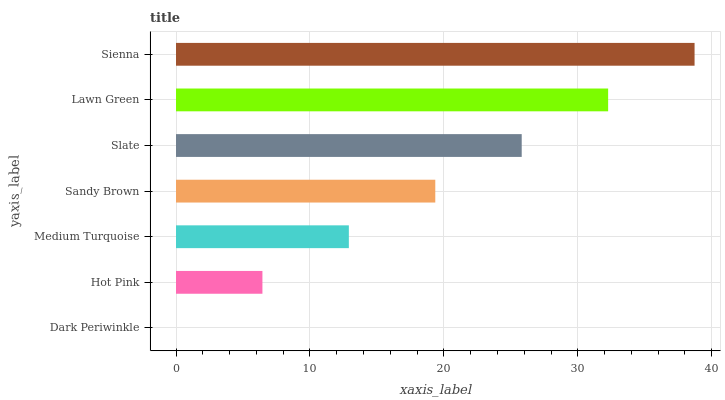Is Dark Periwinkle the minimum?
Answer yes or no. Yes. Is Sienna the maximum?
Answer yes or no. Yes. Is Hot Pink the minimum?
Answer yes or no. No. Is Hot Pink the maximum?
Answer yes or no. No. Is Hot Pink greater than Dark Periwinkle?
Answer yes or no. Yes. Is Dark Periwinkle less than Hot Pink?
Answer yes or no. Yes. Is Dark Periwinkle greater than Hot Pink?
Answer yes or no. No. Is Hot Pink less than Dark Periwinkle?
Answer yes or no. No. Is Sandy Brown the high median?
Answer yes or no. Yes. Is Sandy Brown the low median?
Answer yes or no. Yes. Is Sienna the high median?
Answer yes or no. No. Is Hot Pink the low median?
Answer yes or no. No. 